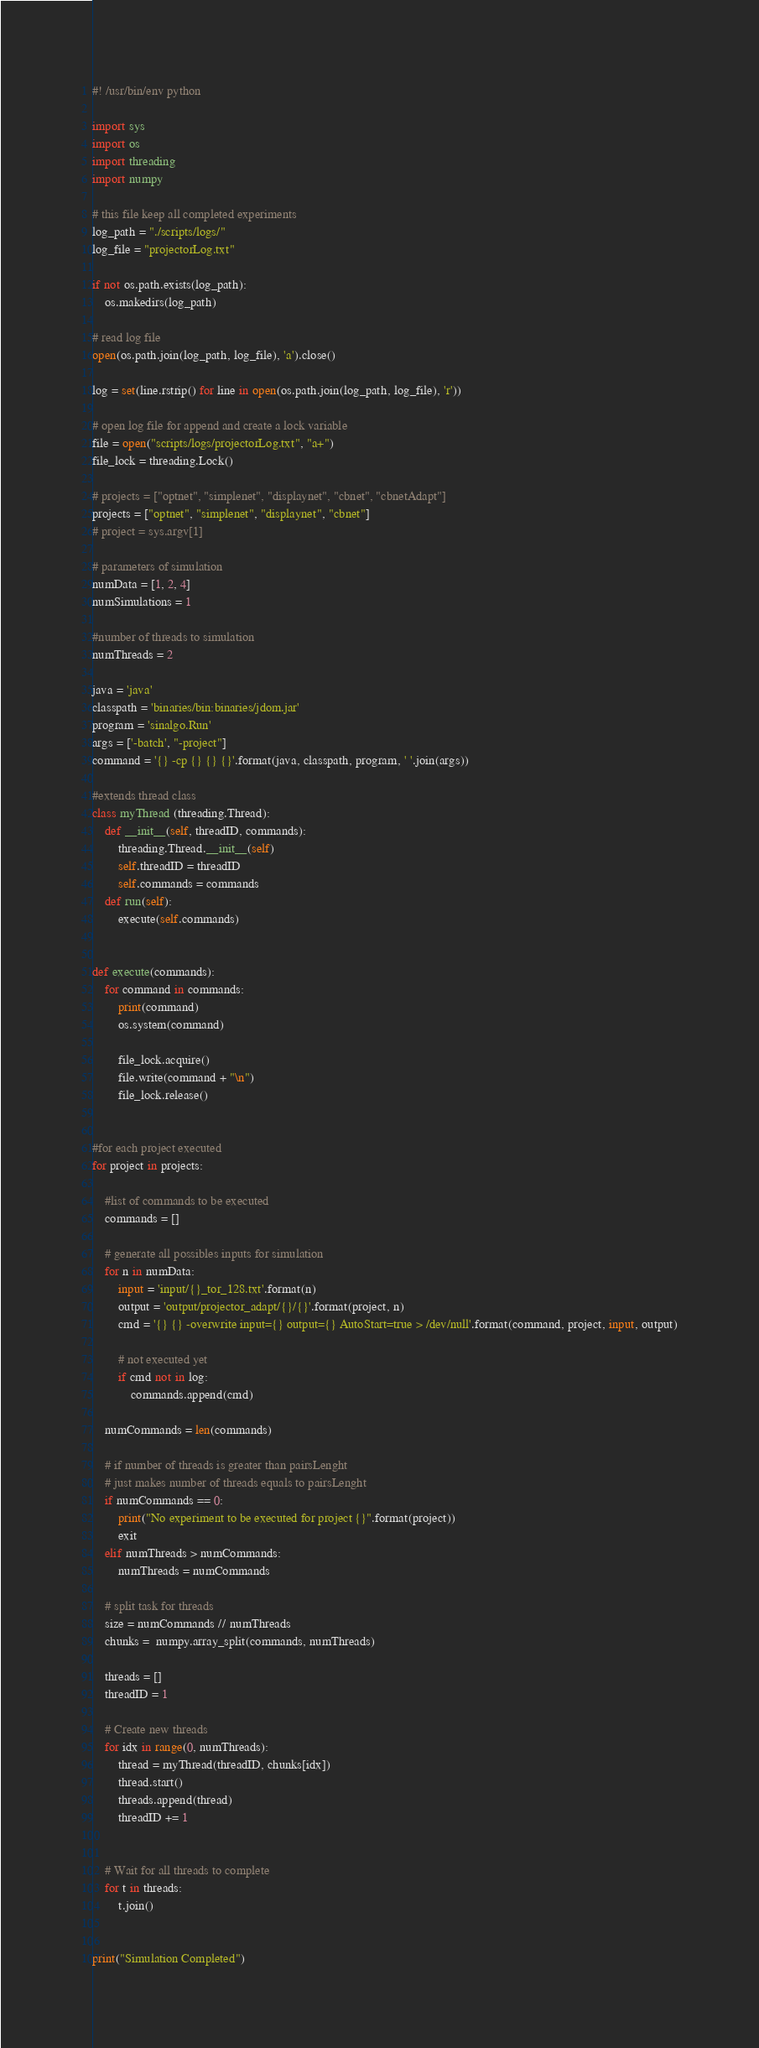Convert code to text. <code><loc_0><loc_0><loc_500><loc_500><_Python_>#! /usr/bin/env python

import sys
import os
import threading
import numpy

# this file keep all completed experiments
log_path = "./scripts/logs/"
log_file = "projectorLog.txt"

if not os.path.exists(log_path):
    os.makedirs(log_path)

# read log file    
open(os.path.join(log_path, log_file), 'a').close()
    
log = set(line.rstrip() for line in open(os.path.join(log_path, log_file), 'r'))

# open log file for append and create a lock variable
file = open("scripts/logs/projectorLog.txt", "a+")
file_lock = threading.Lock()

# projects = ["optnet", "simplenet", "displaynet", "cbnet", "cbnetAdapt"]
projects = ["optnet", "simplenet", "displaynet", "cbnet"]
# project = sys.argv[1]

# parameters of simulation
numData = [1, 2, 4]
numSimulations = 1

#number of threads to simulation
numThreads = 2

java = 'java'
classpath = 'binaries/bin:binaries/jdom.jar'
program = 'sinalgo.Run'
args = ['-batch', "-project"]
command = '{} -cp {} {} {}'.format(java, classpath, program, ' '.join(args))

#extends thread class
class myThread (threading.Thread):
    def __init__(self, threadID, commands):
        threading.Thread.__init__(self)
        self.threadID = threadID
        self.commands = commands
    def run(self):
        execute(self.commands)


def execute(commands):
    for command in commands:
        print(command)
        os.system(command)

        file_lock.acquire()
        file.write(command + "\n")
        file_lock.release()


#for each project executed
for project in projects:

    #list of commands to be executed
    commands = []

    # generate all possibles inputs for simulation
    for n in numData:
        input = 'input/{}_tor_128.txt'.format(n)
        output = 'output/projector_adapt/{}/{}'.format(project, n)
        cmd = '{} {} -overwrite input={} output={} AutoStart=true > /dev/null'.format(command, project, input, output)

        # not executed yet
        if cmd not in log:
            commands.append(cmd)

    numCommands = len(commands)

    # if number of threads is greater than pairsLenght
    # just makes number of threads equals to pairsLenght
    if numCommands == 0:
        print("No experiment to be executed for project {}".format(project))
        exit
    elif numThreads > numCommands:
        numThreads = numCommands

    # split task for threads
    size = numCommands // numThreads
    chunks =  numpy.array_split(commands, numThreads)

    threads = []
    threadID = 1

    # Create new threads
    for idx in range(0, numThreads):
        thread = myThread(threadID, chunks[idx])
        thread.start()
        threads.append(thread)
        threadID += 1


    # Wait for all threads to complete
    for t in threads:
        t.join()


print("Simulation Completed")
</code> 